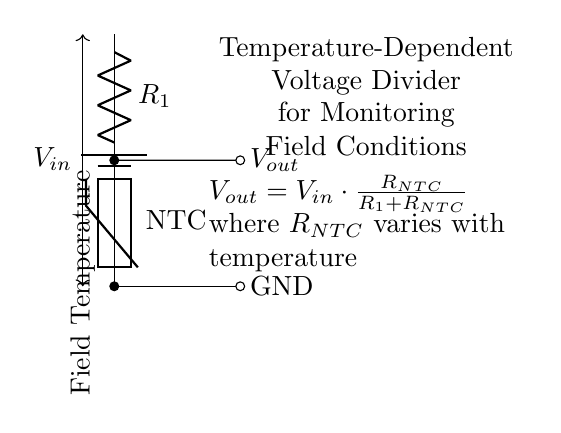what components are in the circuit? The circuit contains a battery, a resistor, and a thermistor. The battery provides the input voltage, the resistor is labeled R1, and the thermistor, which is an NTC type, is connected in the circuit.
Answer: battery, resistor, thermistor what is the function of the thermistor in this circuit? The thermistor is used to measure the temperature, as it varies its resistance with temperature. This variation is what affects the output voltage, making the thermistor essential for monitoring field conditions.
Answer: measure temperature how is the output voltage calculated? The output voltage, Vout, is calculated using the formula: Vout equals Vin multiplied by the ratio of RNTC to the sum of R1 and RNTC. This formula shows how changing resistance due to temperature affects Vout.
Answer: Vout = Vin * (RNTC / (R1 + RNTC)) what type of voltage divider is this circuit? It is a temperature-dependent voltage divider, specifically utilizing an NTC thermistor to alter the resistance based on temperature. This defines how the circuit delivers a varying output voltage in relation to temperature changes.
Answer: temperature-dependent how does increasing temperature affect the output voltage? Increasing temperature decreases the resistance of the NTC thermistor. As RNTC decreases, the ratio in the voltage divider formula changes, leading to an increase in Vout. Hence, Vout becomes higher with higher temperatures.
Answer: increases output voltage what is the significance of the parameter NTC? The parameter NTC stands for Negative Temperature Coefficient, which indicates that the resistance decreases as the temperature increases. This characteristic is crucial for the functioning of the thermistor in this voltage divider application.
Answer: Negative Temperature Coefficient what does the "GND" label denote in the circuit? The "GND" label denotes the ground or reference point in the circuit, providing a common return path for current in the circuit. It is essential for completing the electric circuit and ensuring proper operation.
Answer: ground 